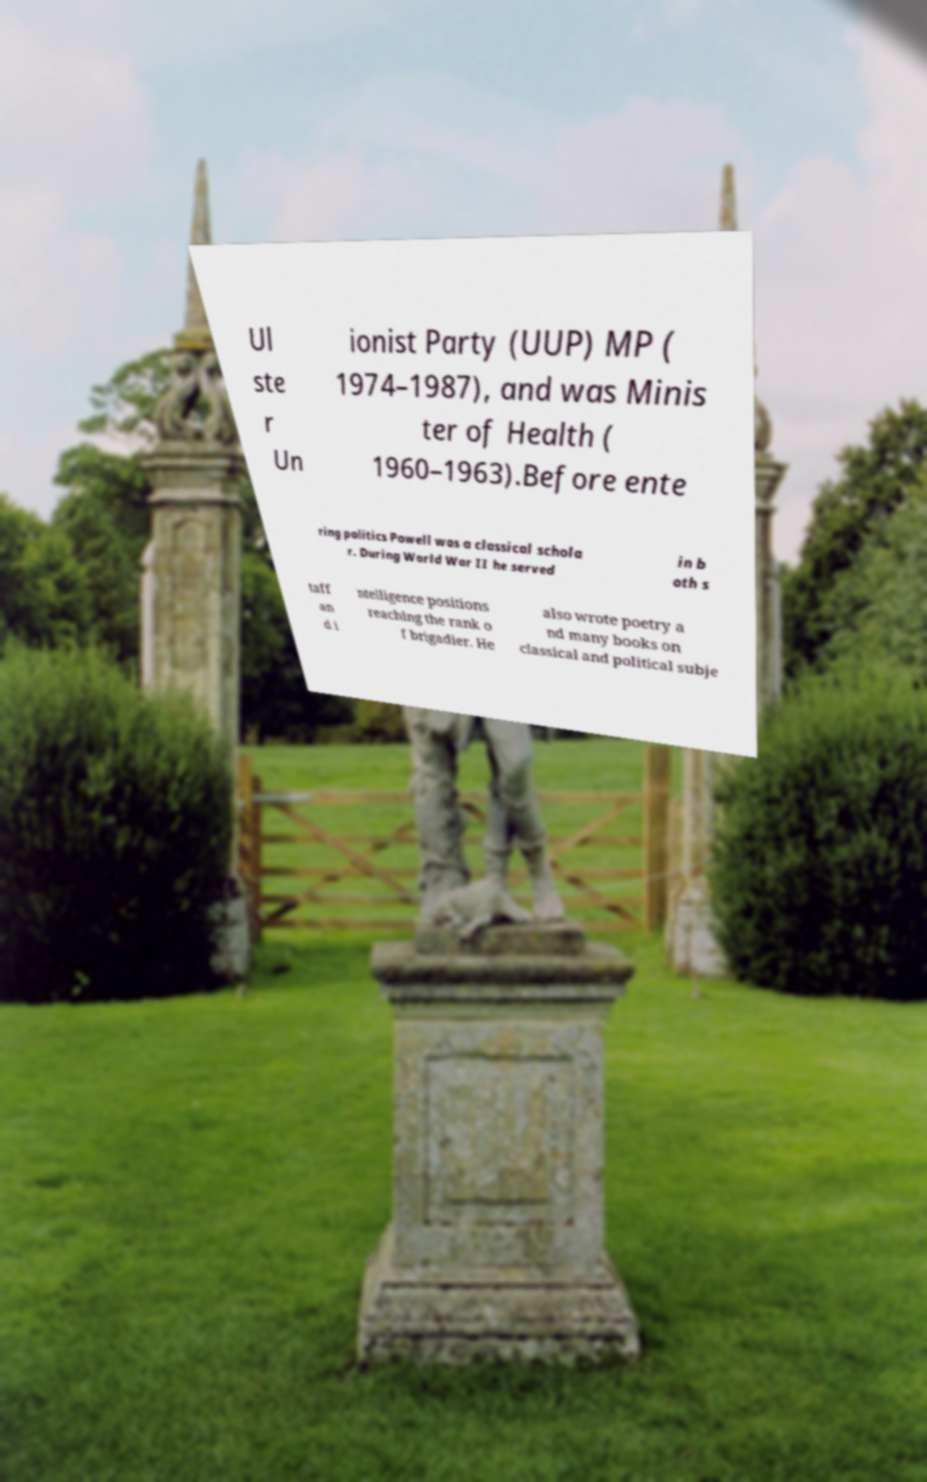What messages or text are displayed in this image? I need them in a readable, typed format. Ul ste r Un ionist Party (UUP) MP ( 1974–1987), and was Minis ter of Health ( 1960–1963).Before ente ring politics Powell was a classical schola r. During World War II he served in b oth s taff an d i ntelligence positions reaching the rank o f brigadier. He also wrote poetry a nd many books on classical and political subje 